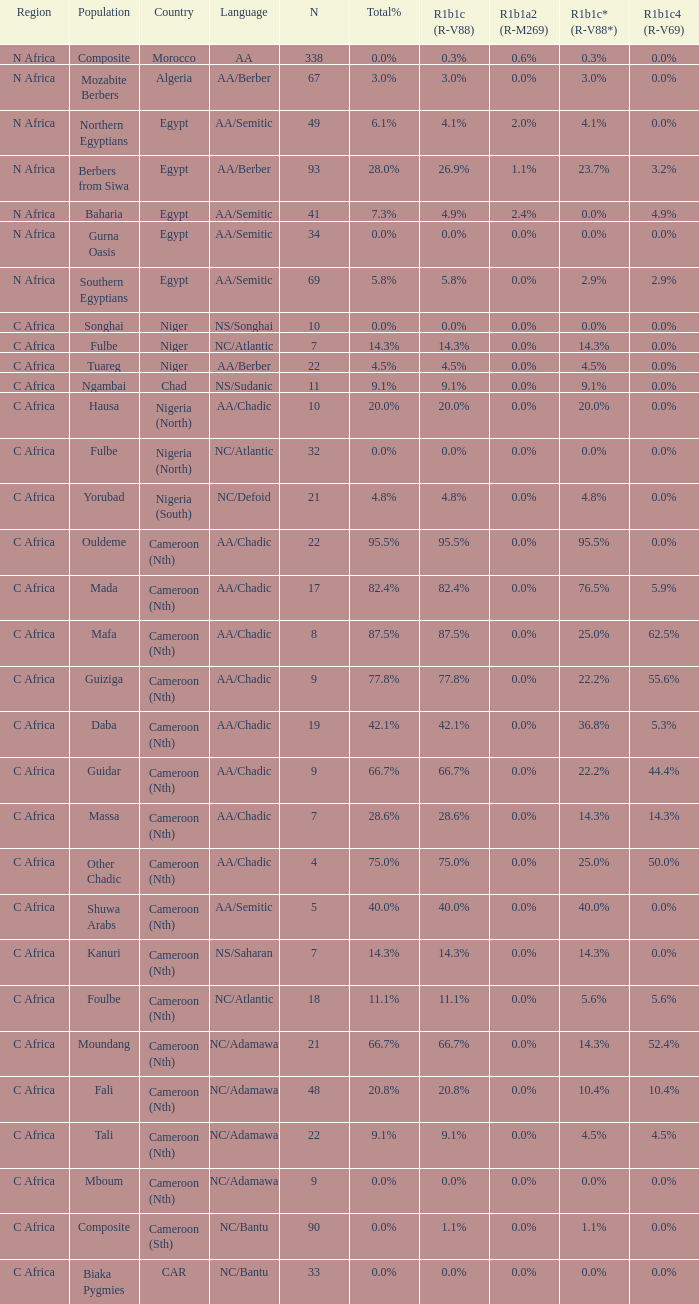How many n are recorded for 1.0. 